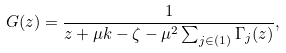<formula> <loc_0><loc_0><loc_500><loc_500>G ( z ) = \frac { 1 } { z + \mu k - \zeta - \mu ^ { 2 } \sum _ { j \in ( 1 ) } \Gamma _ { j } ( z ) } ,</formula> 